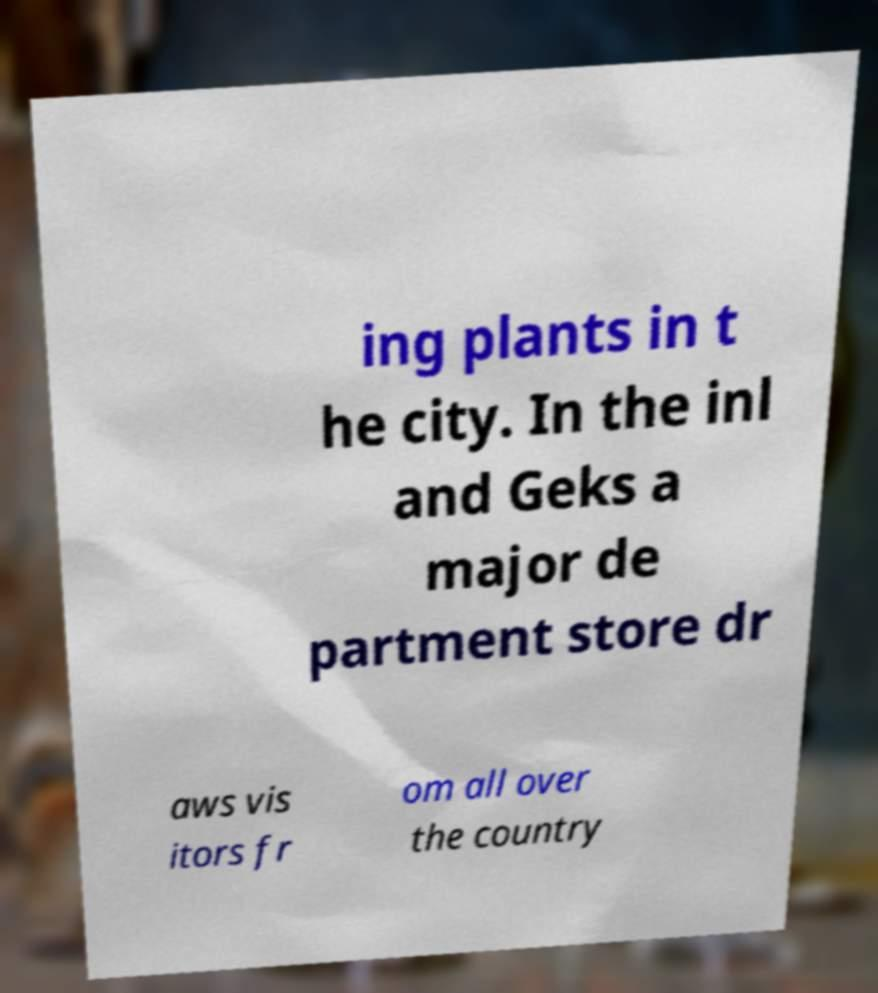Please read and relay the text visible in this image. What does it say? ing plants in t he city. In the inl and Geks a major de partment store dr aws vis itors fr om all over the country 